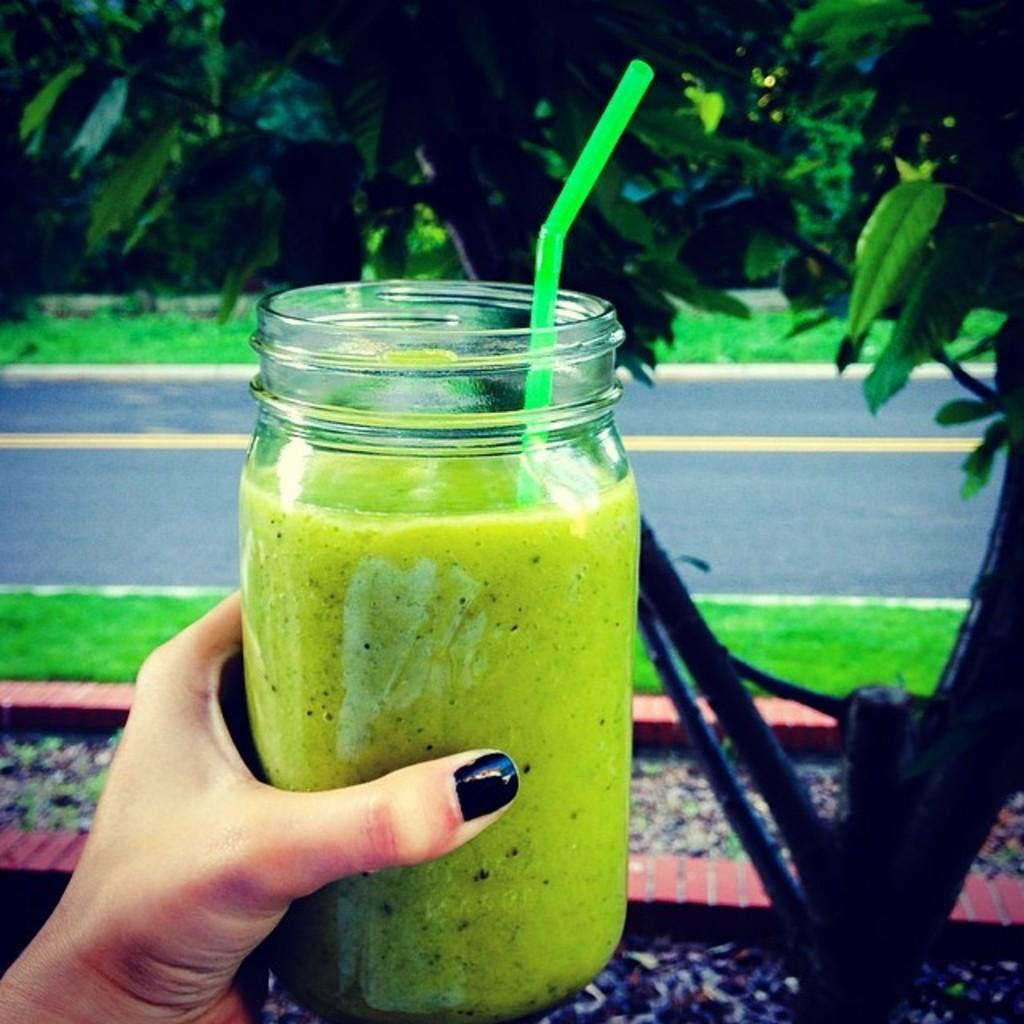Who is present in the image? There is a person in the image. What is the person holding in the image? The person is holding a juice jar. How is the person consuming the juice from the jar? There is a straw in the juice jar, which the person might be using to drink the juice. What type of vegetation is present in the image? The ground is covered with grass. What can be seen in the background of the image? There is a tree and a road visible in the background. What type of sock is the person wearing in the image? There is no sock visible in the image, as the person is wearing shoes. What act is the person performing in the image? The person is not performing any specific act in the image; they are simply holding a juice jar. 